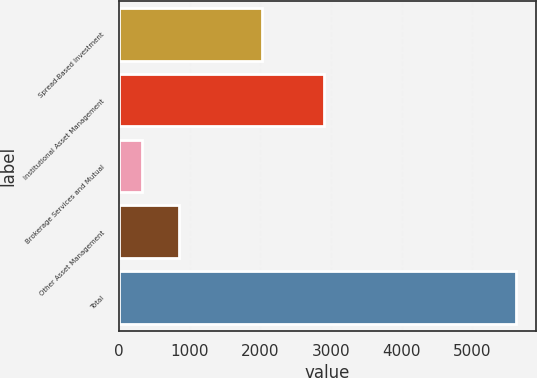Convert chart to OTSL. <chart><loc_0><loc_0><loc_500><loc_500><bar_chart><fcel>Spread-Based Investment<fcel>Institutional Asset Management<fcel>Brokerage Services and Mutual<fcel>Other Asset Management<fcel>Total<nl><fcel>2023<fcel>2900<fcel>322<fcel>852.3<fcel>5625<nl></chart> 